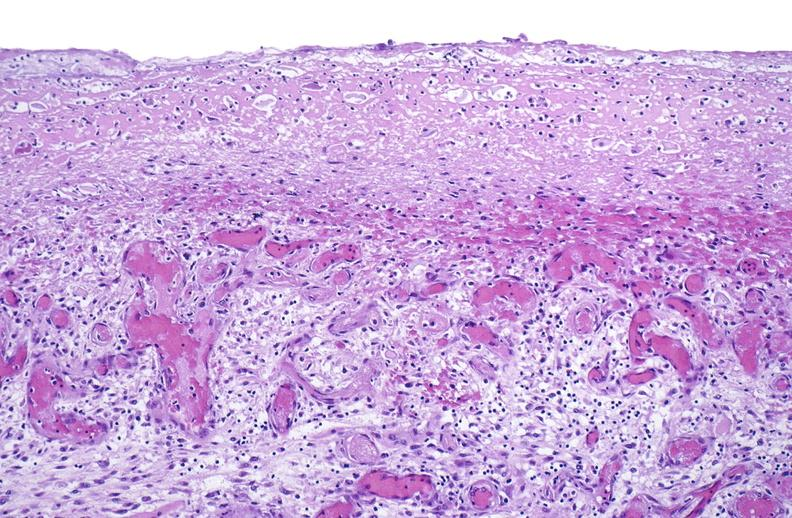what is present?
Answer the question using a single word or phrase. Muscle 